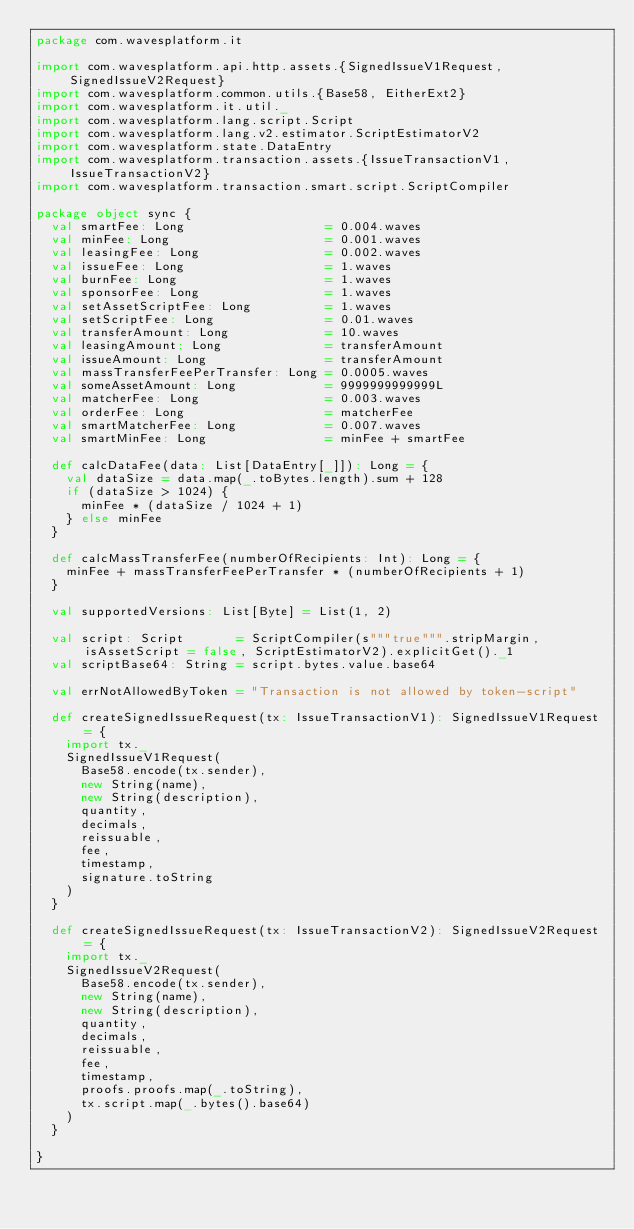Convert code to text. <code><loc_0><loc_0><loc_500><loc_500><_Scala_>package com.wavesplatform.it

import com.wavesplatform.api.http.assets.{SignedIssueV1Request, SignedIssueV2Request}
import com.wavesplatform.common.utils.{Base58, EitherExt2}
import com.wavesplatform.it.util._
import com.wavesplatform.lang.script.Script
import com.wavesplatform.lang.v2.estimator.ScriptEstimatorV2
import com.wavesplatform.state.DataEntry
import com.wavesplatform.transaction.assets.{IssueTransactionV1, IssueTransactionV2}
import com.wavesplatform.transaction.smart.script.ScriptCompiler

package object sync {
  val smartFee: Long                   = 0.004.waves
  val minFee: Long                     = 0.001.waves
  val leasingFee: Long                 = 0.002.waves
  val issueFee: Long                   = 1.waves
  val burnFee: Long                    = 1.waves
  val sponsorFee: Long                 = 1.waves
  val setAssetScriptFee: Long          = 1.waves
  val setScriptFee: Long               = 0.01.waves
  val transferAmount: Long             = 10.waves
  val leasingAmount: Long              = transferAmount
  val issueAmount: Long                = transferAmount
  val massTransferFeePerTransfer: Long = 0.0005.waves
  val someAssetAmount: Long            = 9999999999999L
  val matcherFee: Long                 = 0.003.waves
  val orderFee: Long                   = matcherFee
  val smartMatcherFee: Long            = 0.007.waves
  val smartMinFee: Long                = minFee + smartFee

  def calcDataFee(data: List[DataEntry[_]]): Long = {
    val dataSize = data.map(_.toBytes.length).sum + 128
    if (dataSize > 1024) {
      minFee * (dataSize / 1024 + 1)
    } else minFee
  }

  def calcMassTransferFee(numberOfRecipients: Int): Long = {
    minFee + massTransferFeePerTransfer * (numberOfRecipients + 1)
  }

  val supportedVersions: List[Byte] = List(1, 2)

  val script: Script       = ScriptCompiler(s"""true""".stripMargin, isAssetScript = false, ScriptEstimatorV2).explicitGet()._1
  val scriptBase64: String = script.bytes.value.base64

  val errNotAllowedByToken = "Transaction is not allowed by token-script"

  def createSignedIssueRequest(tx: IssueTransactionV1): SignedIssueV1Request = {
    import tx._
    SignedIssueV1Request(
      Base58.encode(tx.sender),
      new String(name),
      new String(description),
      quantity,
      decimals,
      reissuable,
      fee,
      timestamp,
      signature.toString
    )
  }

  def createSignedIssueRequest(tx: IssueTransactionV2): SignedIssueV2Request = {
    import tx._
    SignedIssueV2Request(
      Base58.encode(tx.sender),
      new String(name),
      new String(description),
      quantity,
      decimals,
      reissuable,
      fee,
      timestamp,
      proofs.proofs.map(_.toString),
      tx.script.map(_.bytes().base64)
    )
  }

}
</code> 